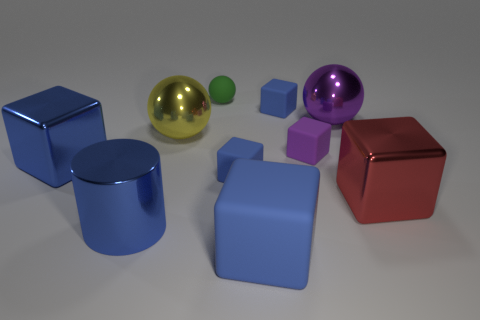Subtract all metal cubes. How many cubes are left? 4 Subtract all yellow cylinders. How many blue cubes are left? 4 Subtract all cubes. How many objects are left? 4 Subtract 4 blocks. How many blocks are left? 2 Subtract all red cubes. How many cubes are left? 5 Subtract all metal cylinders. Subtract all matte objects. How many objects are left? 4 Add 7 small purple rubber things. How many small purple rubber things are left? 8 Add 4 large matte cubes. How many large matte cubes exist? 5 Subtract 0 red spheres. How many objects are left? 10 Subtract all green cubes. Subtract all purple balls. How many cubes are left? 6 